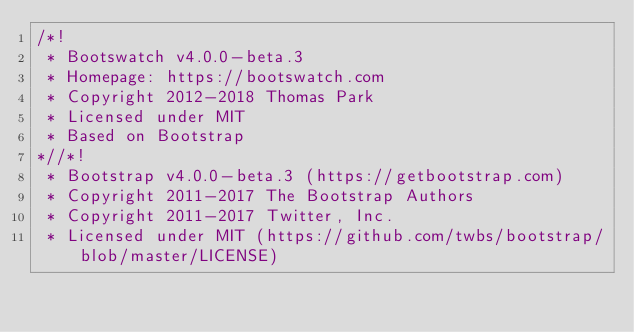Convert code to text. <code><loc_0><loc_0><loc_500><loc_500><_CSS_>/*!
 * Bootswatch v4.0.0-beta.3
 * Homepage: https://bootswatch.com
 * Copyright 2012-2018 Thomas Park
 * Licensed under MIT
 * Based on Bootstrap
*//*!
 * Bootstrap v4.0.0-beta.3 (https://getbootstrap.com)
 * Copyright 2011-2017 The Bootstrap Authors
 * Copyright 2011-2017 Twitter, Inc.
 * Licensed under MIT (https://github.com/twbs/bootstrap/blob/master/LICENSE)</code> 